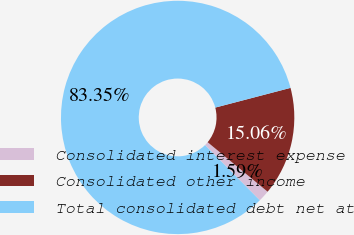Convert chart to OTSL. <chart><loc_0><loc_0><loc_500><loc_500><pie_chart><fcel>Consolidated interest expense<fcel>Consolidated other income<fcel>Total consolidated debt net at<nl><fcel>1.59%<fcel>15.06%<fcel>83.35%<nl></chart> 